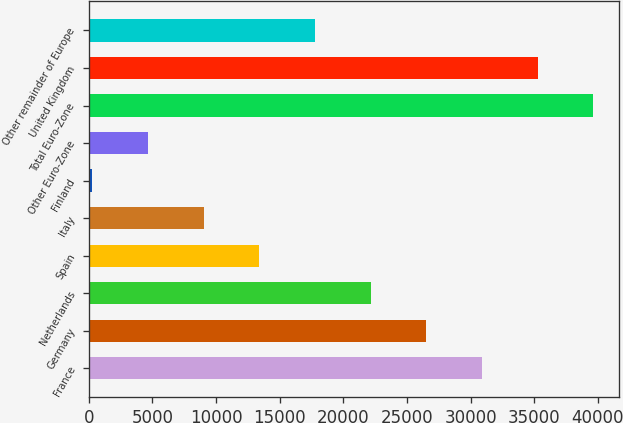Convert chart. <chart><loc_0><loc_0><loc_500><loc_500><bar_chart><fcel>France<fcel>Germany<fcel>Netherlands<fcel>Spain<fcel>Italy<fcel>Finland<fcel>Other Euro-Zone<fcel>Total Euro-Zone<fcel>United Kingdom<fcel>Other remainder of Europe<nl><fcel>30903.2<fcel>26528.6<fcel>22154<fcel>13404.8<fcel>9030.2<fcel>281<fcel>4655.6<fcel>39652.4<fcel>35277.8<fcel>17779.4<nl></chart> 